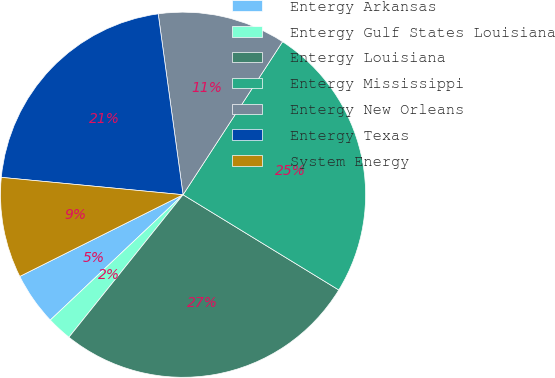<chart> <loc_0><loc_0><loc_500><loc_500><pie_chart><fcel>Entergy Arkansas<fcel>Entergy Gulf States Louisiana<fcel>Entergy Louisiana<fcel>Entergy Mississippi<fcel>Entergy New Orleans<fcel>Entergy Texas<fcel>System Energy<nl><fcel>4.66%<fcel>2.21%<fcel>27.01%<fcel>24.56%<fcel>11.35%<fcel>21.31%<fcel>8.9%<nl></chart> 